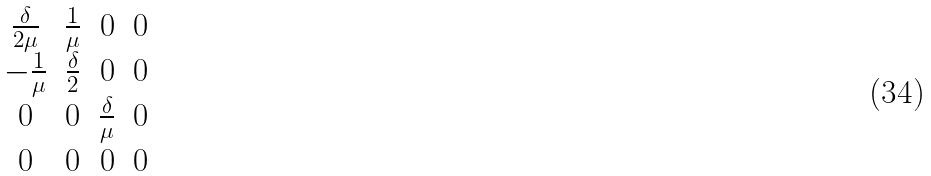<formula> <loc_0><loc_0><loc_500><loc_500>\begin{matrix} \frac { \delta } { 2 \mu } & \frac { 1 } { \mu } & 0 & 0 \\ - \frac { 1 } { \mu } & \frac { \delta } { 2 } & 0 & 0 \\ 0 & 0 & \frac { \delta } { \mu } & 0 \\ 0 & 0 & 0 & 0 \end{matrix}</formula> 